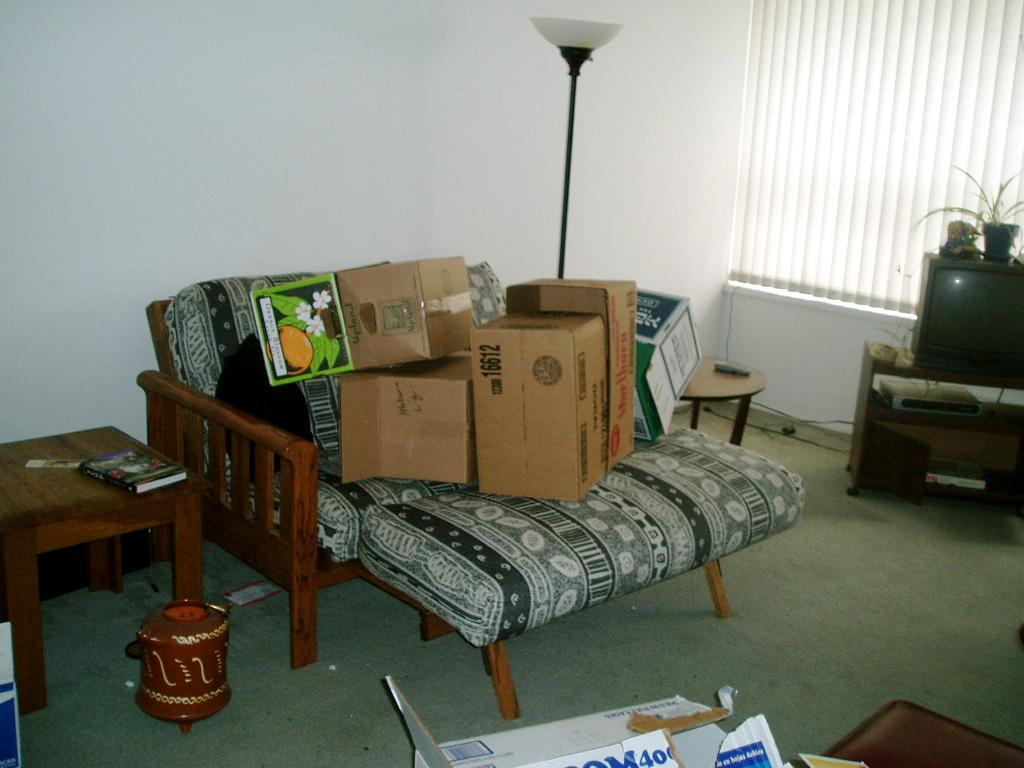What type of furniture is located on the left side of the image? There is a wooden table on the left side of the image. What is placed on the wooden table? There is a book on the wooden table. What type of electronic device is located on the right side of the image? There is a television on the right side of the image. How many parts of the orange can be seen in the image? There is no orange present in the image. What is the cent of the book on the wooden table? The question is absurd because it refers to a percentage of a book, which is not a measurable quantity in this context. 